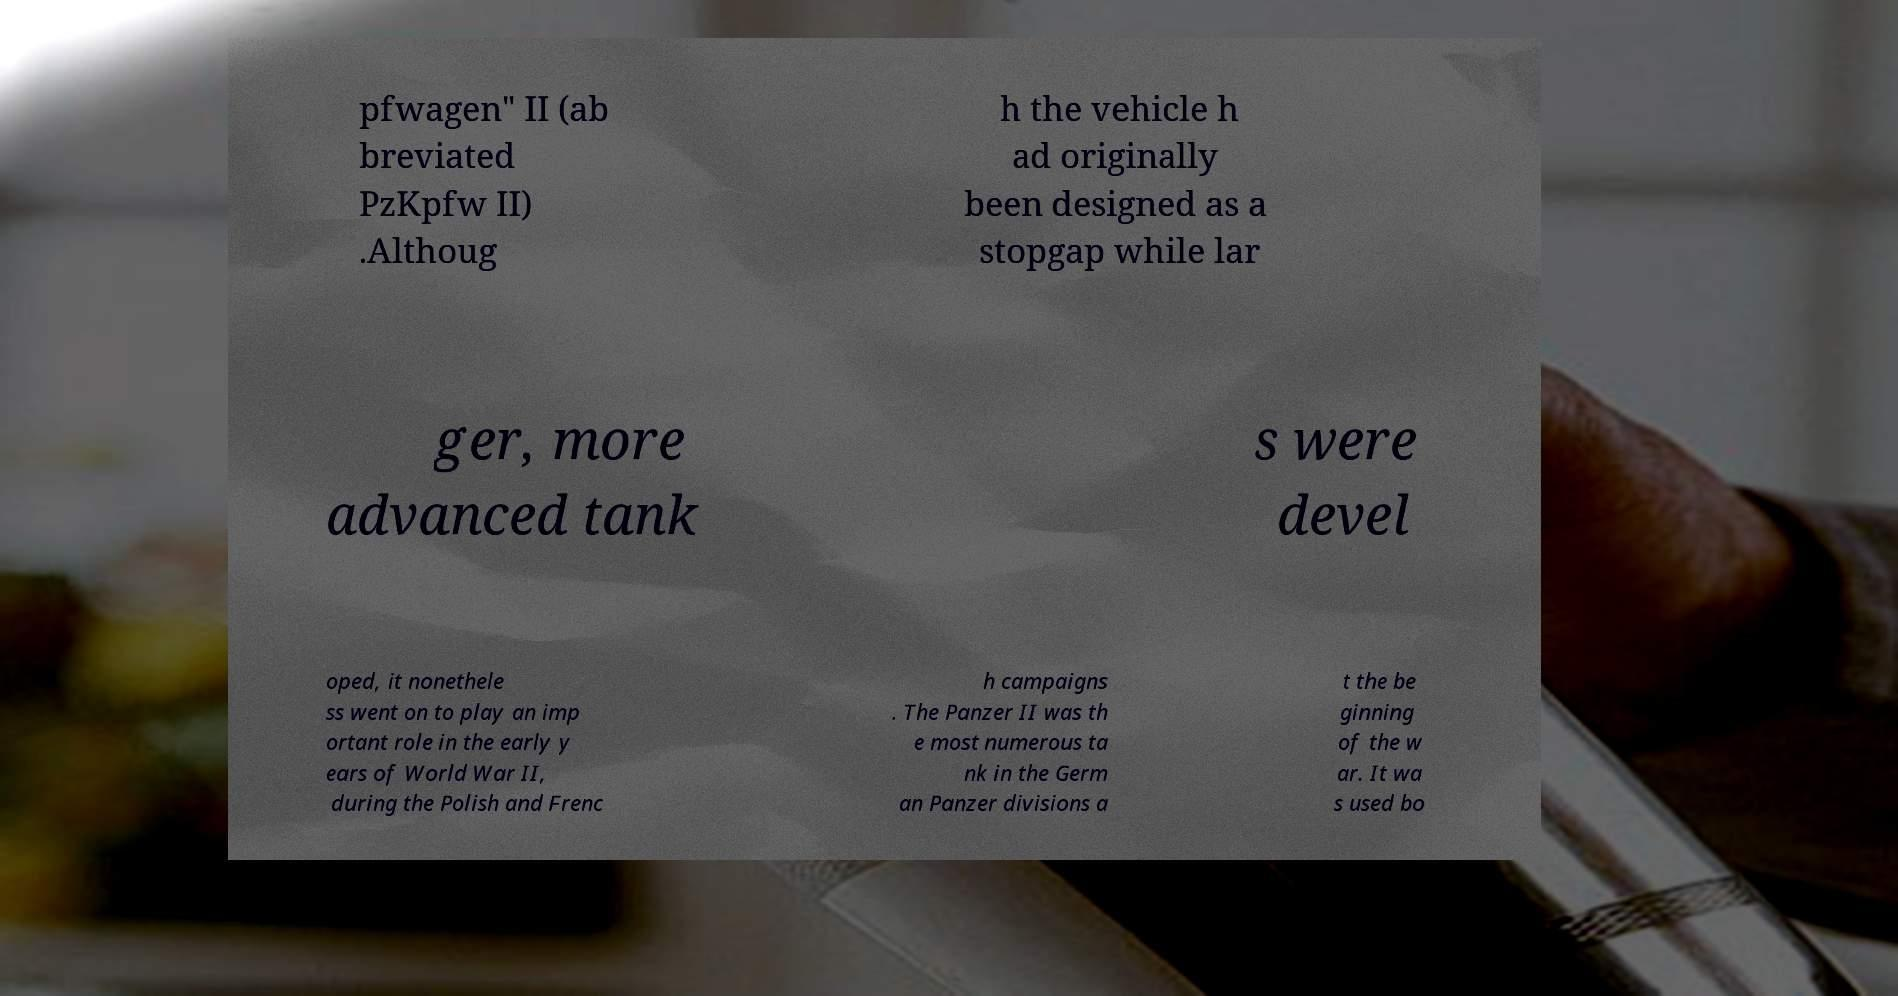Could you extract and type out the text from this image? pfwagen" II (ab breviated PzKpfw II) .Althoug h the vehicle h ad originally been designed as a stopgap while lar ger, more advanced tank s were devel oped, it nonethele ss went on to play an imp ortant role in the early y ears of World War II, during the Polish and Frenc h campaigns . The Panzer II was th e most numerous ta nk in the Germ an Panzer divisions a t the be ginning of the w ar. It wa s used bo 